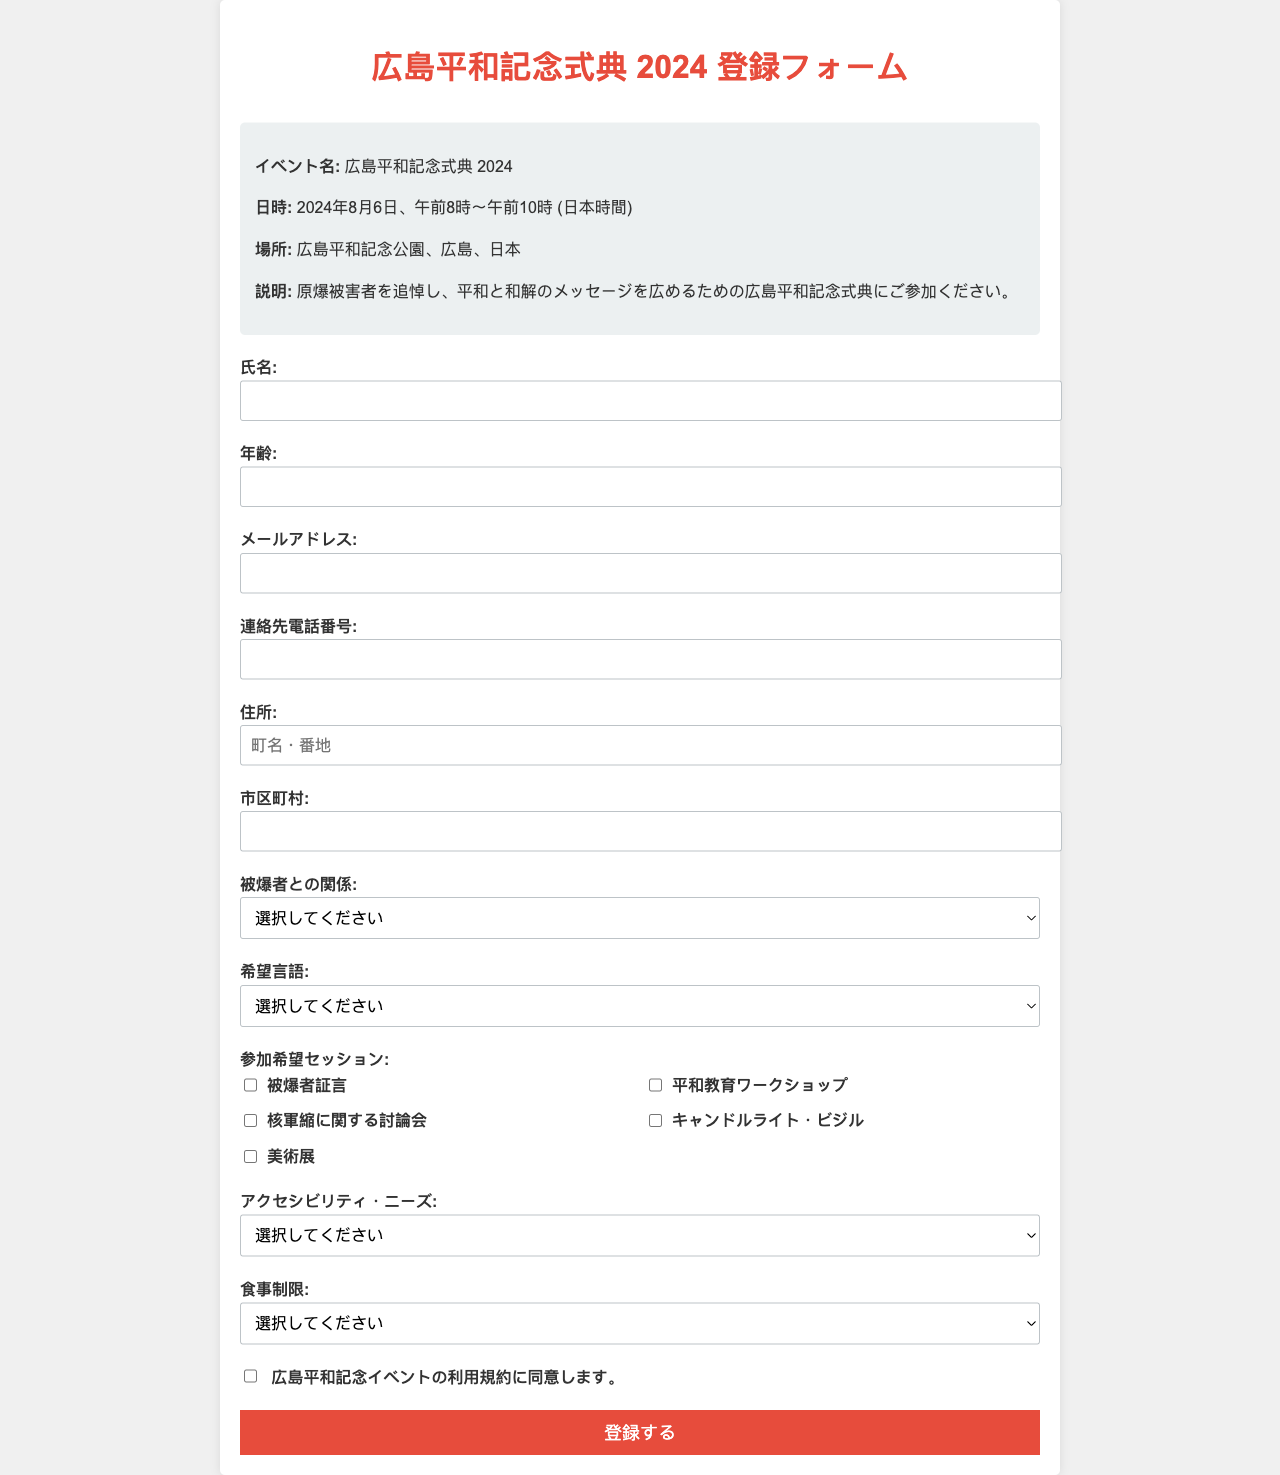What is the event date? The event date is clearly mentioned in the "日時" section of the document, which states "2024年8月6日".
Answer: 2024年8月6日 What is the location of the event? The specific location is provided in the "場所" section, which indicates "広島平和記念公園、広島、日本".
Answer: 広島平和記念公園、広島、日本 What is the maximum age for participants? The form requires participants to fill in their age, but there is no specified maximum age mentioned in the document.
Answer: No maximum age specified What is the required language for communication? The "希望言語" section indicates available language options, with "日本語" and "英語" being the primary choices.
Answer: 日本語, 英語 What must participants agree to in order to register? The document specifies that participants must agree to the "広島平和記念イベントの利用規約" before submitting the registration form.
Answer: 広島平和記念イベントの利用規約 Which session focuses on nuclear disarmament? The checkbox item labeled "核軍縮に関する討論会" refers to the session discussing nuclear disarmament.
Answer: 核軍縮に関する討論会 Who is eligible to participate as a family member? The "被爆者との関係" selection includes the option "被爆者の家族", making it clear that family members of victims can register.
Answer: 被爆者の家族 Which accessibility need options are provided? The "アクセシビリティ・ニーズ" section lists several choices such as "車椅子アクセス" and "手話通訳".
Answer: 車椅子アクセス, 手話通訳 What type of meal options are offered? The document allows participants to select meal preferences including "ベジタリアン", "ビーガン", and "ハラール".
Answer: ベジタリアン, ビーガン, ハラール 